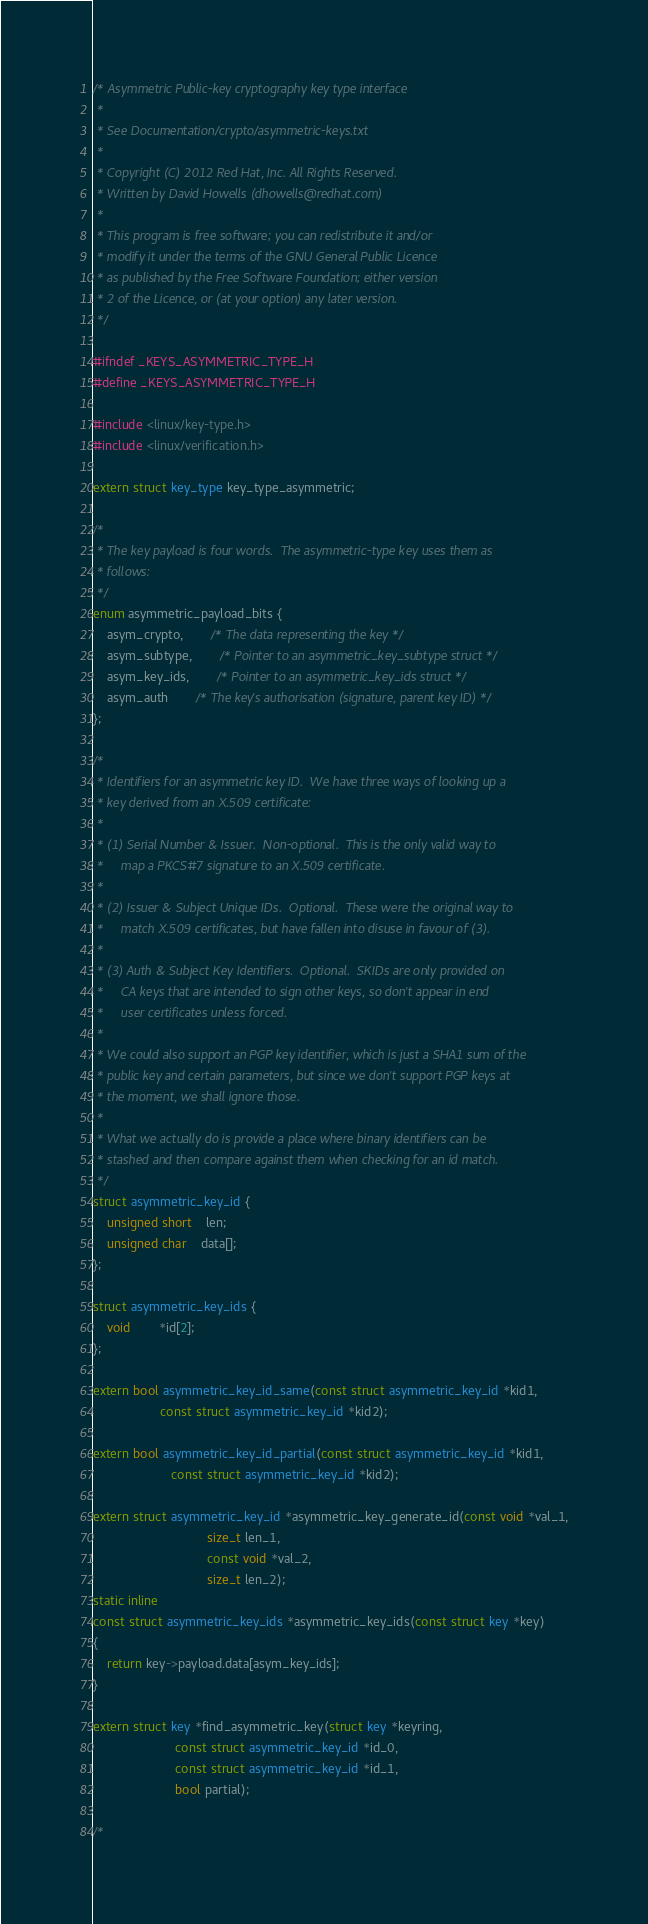Convert code to text. <code><loc_0><loc_0><loc_500><loc_500><_C_>/* Asymmetric Public-key cryptography key type interface
 *
 * See Documentation/crypto/asymmetric-keys.txt
 *
 * Copyright (C) 2012 Red Hat, Inc. All Rights Reserved.
 * Written by David Howells (dhowells@redhat.com)
 *
 * This program is free software; you can redistribute it and/or
 * modify it under the terms of the GNU General Public Licence
 * as published by the Free Software Foundation; either version
 * 2 of the Licence, or (at your option) any later version.
 */

#ifndef _KEYS_ASYMMETRIC_TYPE_H
#define _KEYS_ASYMMETRIC_TYPE_H

#include <linux/key-type.h>
#include <linux/verification.h>

extern struct key_type key_type_asymmetric;

/*
 * The key payload is four words.  The asymmetric-type key uses them as
 * follows:
 */
enum asymmetric_payload_bits {
	asym_crypto,		/* The data representing the key */
	asym_subtype,		/* Pointer to an asymmetric_key_subtype struct */
	asym_key_ids,		/* Pointer to an asymmetric_key_ids struct */
	asym_auth		/* The key's authorisation (signature, parent key ID) */
};

/*
 * Identifiers for an asymmetric key ID.  We have three ways of looking up a
 * key derived from an X.509 certificate:
 *
 * (1) Serial Number & Issuer.  Non-optional.  This is the only valid way to
 *     map a PKCS#7 signature to an X.509 certificate.
 *
 * (2) Issuer & Subject Unique IDs.  Optional.  These were the original way to
 *     match X.509 certificates, but have fallen into disuse in favour of (3).
 *
 * (3) Auth & Subject Key Identifiers.  Optional.  SKIDs are only provided on
 *     CA keys that are intended to sign other keys, so don't appear in end
 *     user certificates unless forced.
 *
 * We could also support an PGP key identifier, which is just a SHA1 sum of the
 * public key and certain parameters, but since we don't support PGP keys at
 * the moment, we shall ignore those.
 *
 * What we actually do is provide a place where binary identifiers can be
 * stashed and then compare against them when checking for an id match.
 */
struct asymmetric_key_id {
	unsigned short	len;
	unsigned char	data[];
};

struct asymmetric_key_ids {
	void		*id[2];
};

extern bool asymmetric_key_id_same(const struct asymmetric_key_id *kid1,
				   const struct asymmetric_key_id *kid2);

extern bool asymmetric_key_id_partial(const struct asymmetric_key_id *kid1,
				      const struct asymmetric_key_id *kid2);

extern struct asymmetric_key_id *asymmetric_key_generate_id(const void *val_1,
							    size_t len_1,
							    const void *val_2,
							    size_t len_2);
static inline
const struct asymmetric_key_ids *asymmetric_key_ids(const struct key *key)
{
	return key->payload.data[asym_key_ids];
}

extern struct key *find_asymmetric_key(struct key *keyring,
				       const struct asymmetric_key_id *id_0,
				       const struct asymmetric_key_id *id_1,
				       bool partial);

/*</code> 